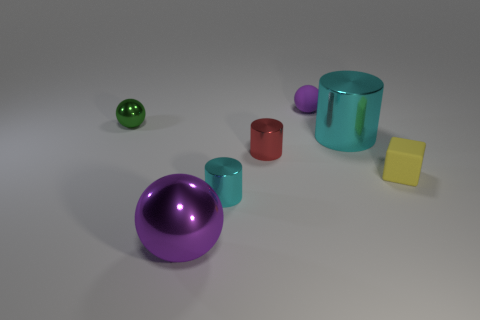Subtract all big spheres. How many spheres are left? 2 Add 3 purple spheres. How many objects exist? 10 Subtract all green balls. How many balls are left? 2 Subtract all purple cubes. How many purple spheres are left? 2 Subtract 0 yellow cylinders. How many objects are left? 7 Subtract all cubes. How many objects are left? 6 Subtract all yellow spheres. Subtract all cyan cylinders. How many spheres are left? 3 Subtract all big blue metal cubes. Subtract all large cyan shiny objects. How many objects are left? 6 Add 3 small matte cubes. How many small matte cubes are left? 4 Add 4 shiny blocks. How many shiny blocks exist? 4 